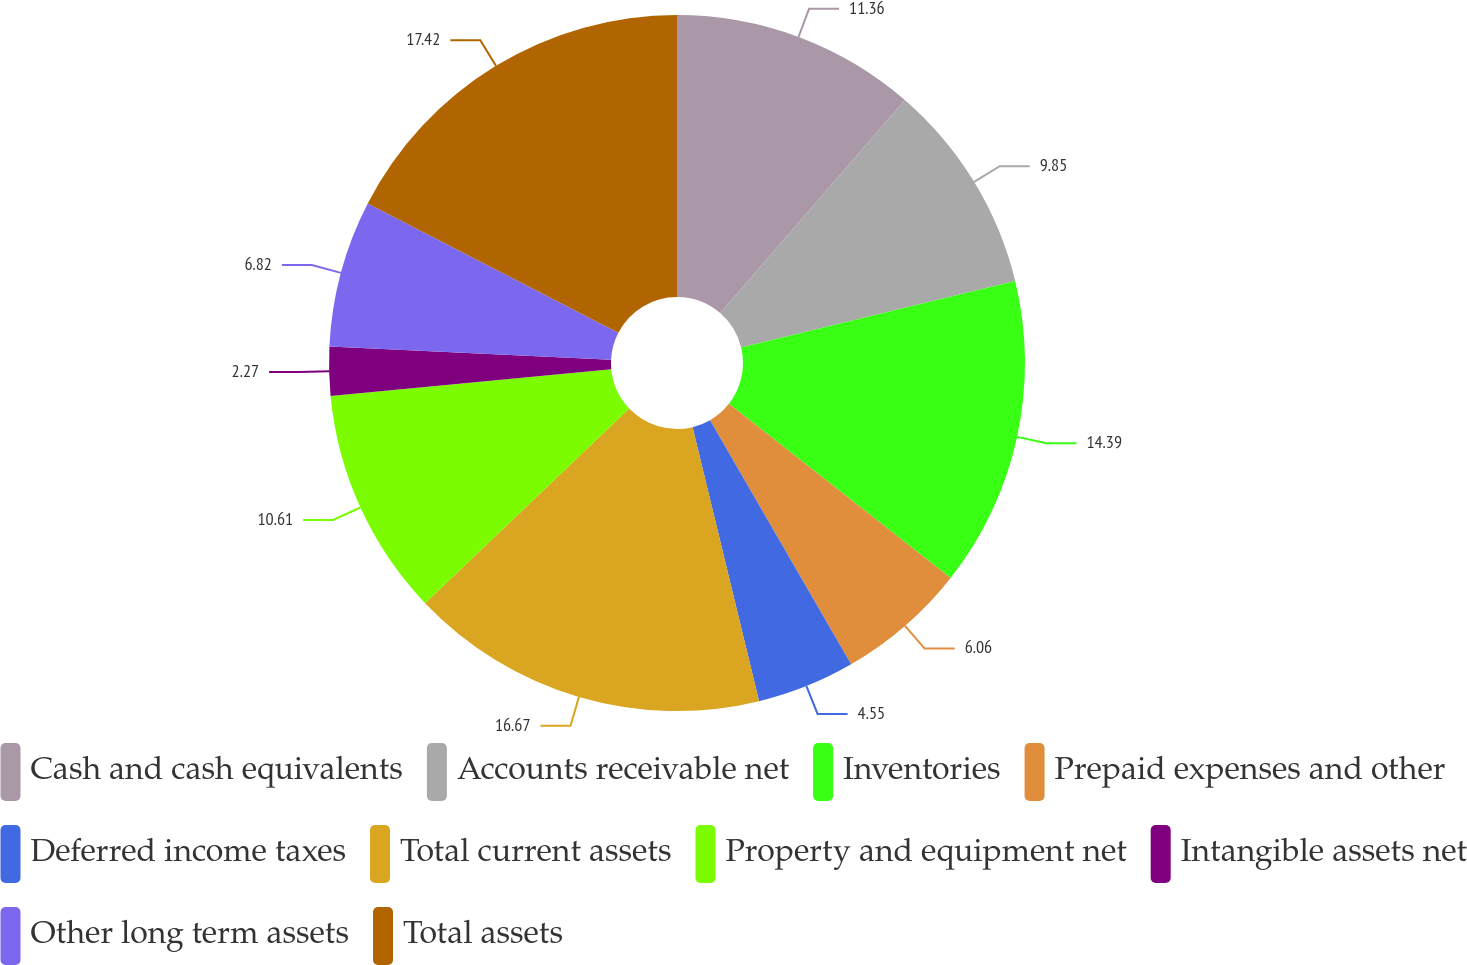Convert chart. <chart><loc_0><loc_0><loc_500><loc_500><pie_chart><fcel>Cash and cash equivalents<fcel>Accounts receivable net<fcel>Inventories<fcel>Prepaid expenses and other<fcel>Deferred income taxes<fcel>Total current assets<fcel>Property and equipment net<fcel>Intangible assets net<fcel>Other long term assets<fcel>Total assets<nl><fcel>11.36%<fcel>9.85%<fcel>14.39%<fcel>6.06%<fcel>4.55%<fcel>16.67%<fcel>10.61%<fcel>2.27%<fcel>6.82%<fcel>17.42%<nl></chart> 